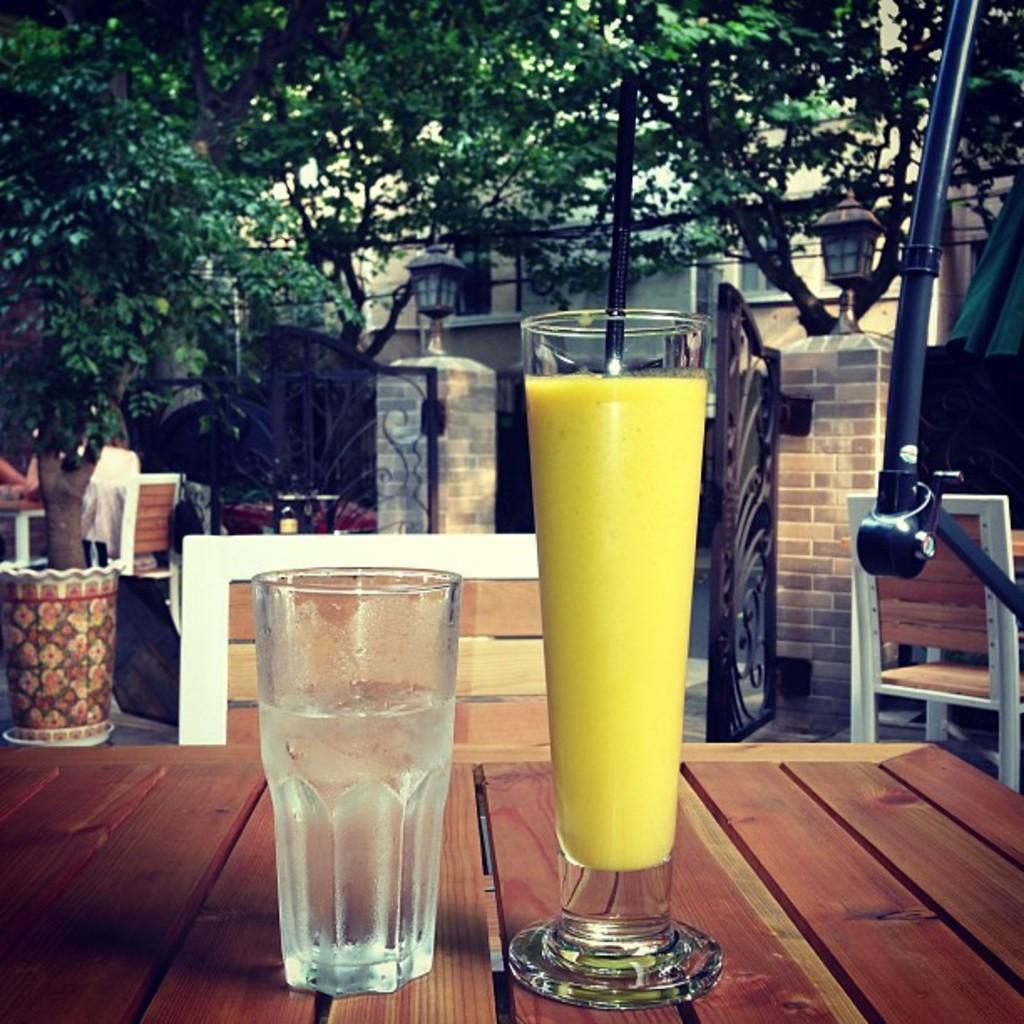Can you describe this image briefly? In this picture we can see two glasses with drink in it and these glasses are on the table and in the background we can see chairs, building, trees, lights and few objects. 